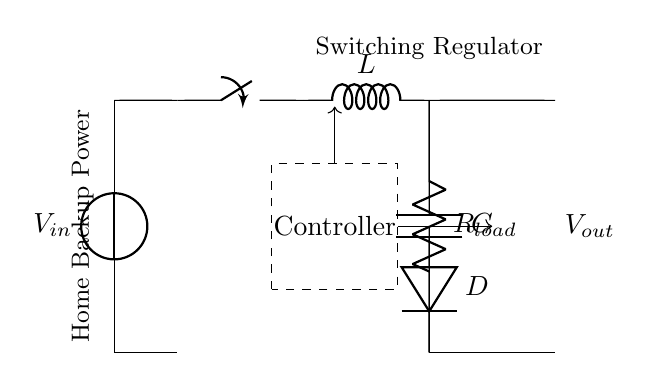What is the input voltage of the circuit? The input voltage is represented by \( V_{in} \), which is labeled next to the voltage source in the circuit.
Answer: \( V_{in} \) What component regulates the output voltage? The component that controls the output voltage levels is indicated as the "Controller" in the dashed rectangle.
Answer: Controller What type of inductor is used in this circuit? The circuit uses an inductor represented by the symbol \( L \). This component is essential in a switching regulator for energy storage.
Answer: L What is the function of the diode in this circuit? The diode, labeled \( D \), allows current to flow in one direction and is used to prevent backflow, which protects the circuit components during switching.
Answer: Prevent backflow What role does the capacitor play in this circuit? The capacitor, labeled \( C \), smooths the output voltage by storing and releasing charge, which reduces voltage ripples on the load side.
Answer: Smooths output voltage How does the switching regulator achieve efficient power management? The switching regulator achieves efficient power management by rapidly switching the input voltage on and off, which optimizes power conversion and minimizes heat loss compared to linear regulators.
Answer: Optimizes power conversion What is the load resistance denoted as in the circuit? The load resistance is represented by \( R_{load} \), indicating the component that consumes the power supplied by the regulator circuit.
Answer: \( R_{load} \) 